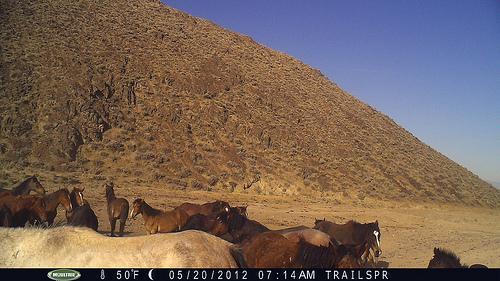How many clouds are in the sky?
Give a very brief answer. 0. How many dinosaurs are in the picture?
Give a very brief answer. 0. How many people are riding on elephants?
Give a very brief answer. 0. How many elephants are pictured?
Give a very brief answer. 0. 